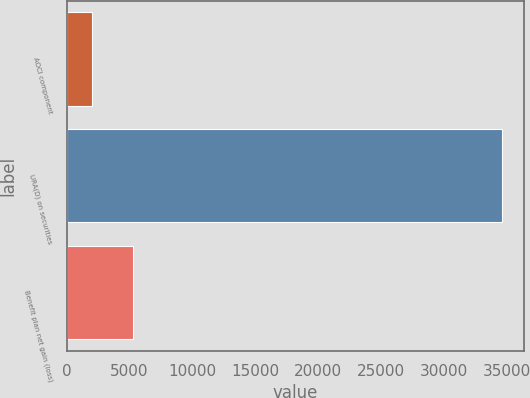Convert chart. <chart><loc_0><loc_0><loc_500><loc_500><bar_chart><fcel>AOCI component<fcel>URA(D) on securities<fcel>Benefit plan net gain (loss)<nl><fcel>2014<fcel>34668<fcel>5279.4<nl></chart> 